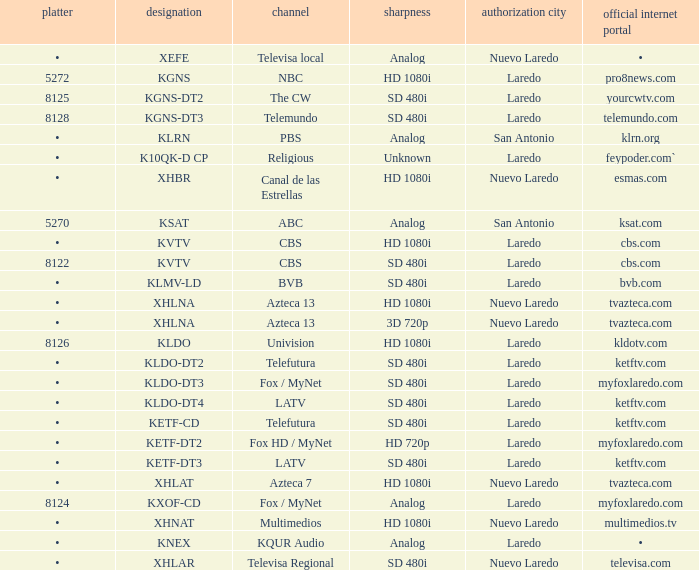Name the resolution with dish of 8126 HD 1080i. Write the full table. {'header': ['platter', 'designation', 'channel', 'sharpness', 'authorization city', 'official internet portal'], 'rows': [['•', 'XEFE', 'Televisa local', 'Analog', 'Nuevo Laredo', '•'], ['5272', 'KGNS', 'NBC', 'HD 1080i', 'Laredo', 'pro8news.com'], ['8125', 'KGNS-DT2', 'The CW', 'SD 480i', 'Laredo', 'yourcwtv.com'], ['8128', 'KGNS-DT3', 'Telemundo', 'SD 480i', 'Laredo', 'telemundo.com'], ['•', 'KLRN', 'PBS', 'Analog', 'San Antonio', 'klrn.org'], ['•', 'K10QK-D CP', 'Religious', 'Unknown', 'Laredo', 'feypoder.com`'], ['•', 'XHBR', 'Canal de las Estrellas', 'HD 1080i', 'Nuevo Laredo', 'esmas.com'], ['5270', 'KSAT', 'ABC', 'Analog', 'San Antonio', 'ksat.com'], ['•', 'KVTV', 'CBS', 'HD 1080i', 'Laredo', 'cbs.com'], ['8122', 'KVTV', 'CBS', 'SD 480i', 'Laredo', 'cbs.com'], ['•', 'KLMV-LD', 'BVB', 'SD 480i', 'Laredo', 'bvb.com'], ['•', 'XHLNA', 'Azteca 13', 'HD 1080i', 'Nuevo Laredo', 'tvazteca.com'], ['•', 'XHLNA', 'Azteca 13', '3D 720p', 'Nuevo Laredo', 'tvazteca.com'], ['8126', 'KLDO', 'Univision', 'HD 1080i', 'Laredo', 'kldotv.com'], ['•', 'KLDO-DT2', 'Telefutura', 'SD 480i', 'Laredo', 'ketftv.com'], ['•', 'KLDO-DT3', 'Fox / MyNet', 'SD 480i', 'Laredo', 'myfoxlaredo.com'], ['•', 'KLDO-DT4', 'LATV', 'SD 480i', 'Laredo', 'ketftv.com'], ['•', 'KETF-CD', 'Telefutura', 'SD 480i', 'Laredo', 'ketftv.com'], ['•', 'KETF-DT2', 'Fox HD / MyNet', 'HD 720p', 'Laredo', 'myfoxlaredo.com'], ['•', 'KETF-DT3', 'LATV', 'SD 480i', 'Laredo', 'ketftv.com'], ['•', 'XHLAT', 'Azteca 7', 'HD 1080i', 'Nuevo Laredo', 'tvazteca.com'], ['8124', 'KXOF-CD', 'Fox / MyNet', 'Analog', 'Laredo', 'myfoxlaredo.com'], ['•', 'XHNAT', 'Multimedios', 'HD 1080i', 'Nuevo Laredo', 'multimedios.tv'], ['•', 'KNEX', 'KQUR Audio', 'Analog', 'Laredo', '•'], ['•', 'XHLAR', 'Televisa Regional', 'SD 480i', 'Nuevo Laredo', 'televisa.com']]} 